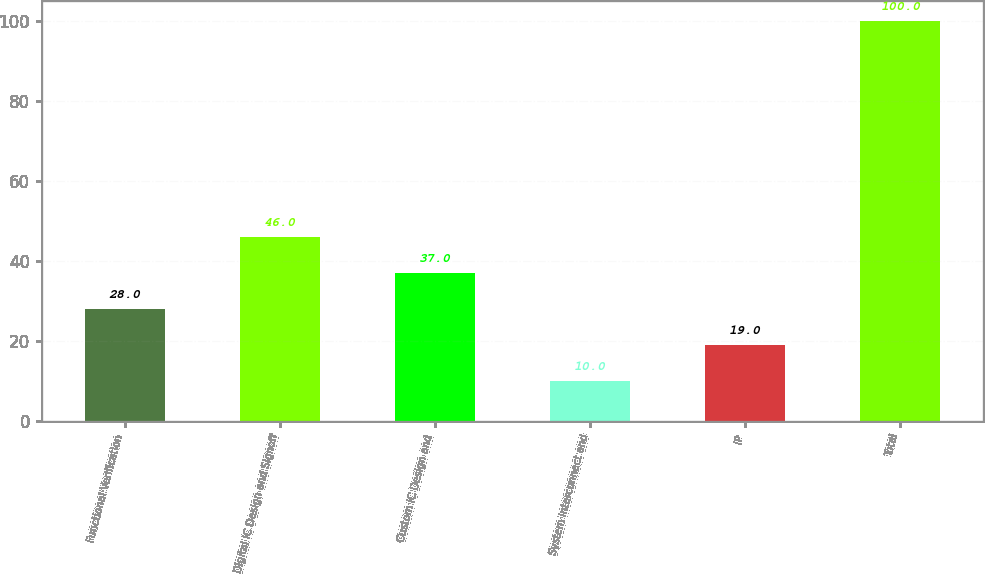Convert chart. <chart><loc_0><loc_0><loc_500><loc_500><bar_chart><fcel>Functional Verification<fcel>Digital IC Design and Signoff<fcel>Custom IC Design and<fcel>System Interconnect and<fcel>IP<fcel>Total<nl><fcel>28<fcel>46<fcel>37<fcel>10<fcel>19<fcel>100<nl></chart> 